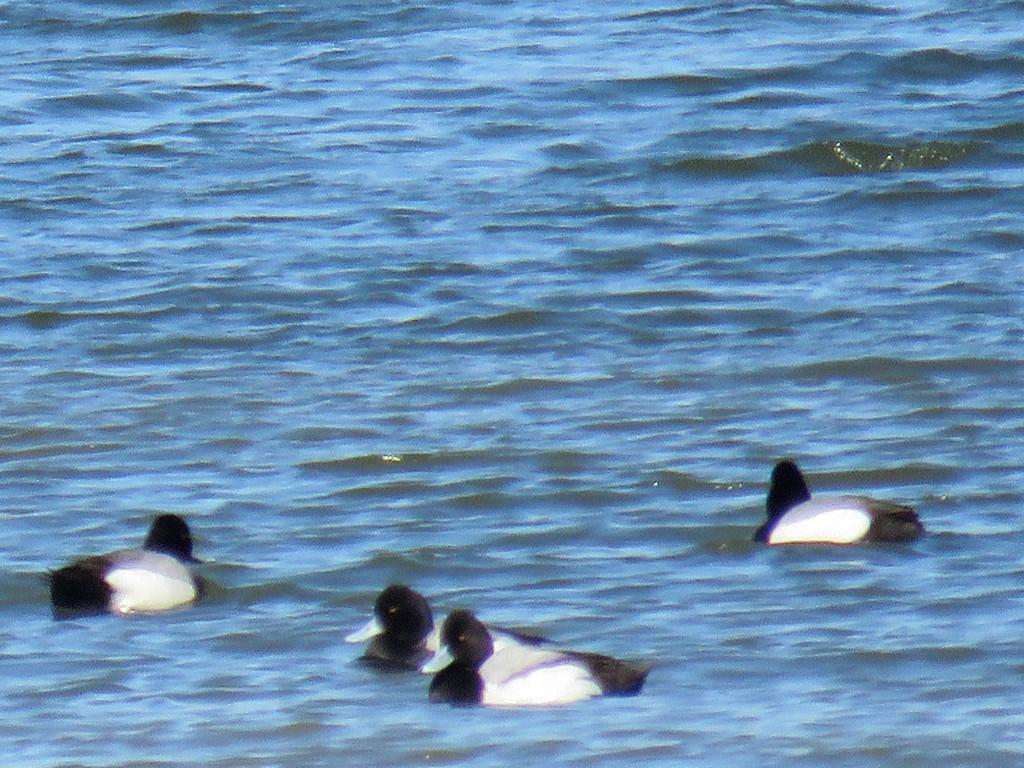How would you summarize this image in a sentence or two? In this image there are birds in the foreground. And there is water at the bottom. 